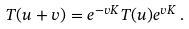<formula> <loc_0><loc_0><loc_500><loc_500>T ( u + v ) = e ^ { - v K } T ( u ) e ^ { v K } \, .</formula> 